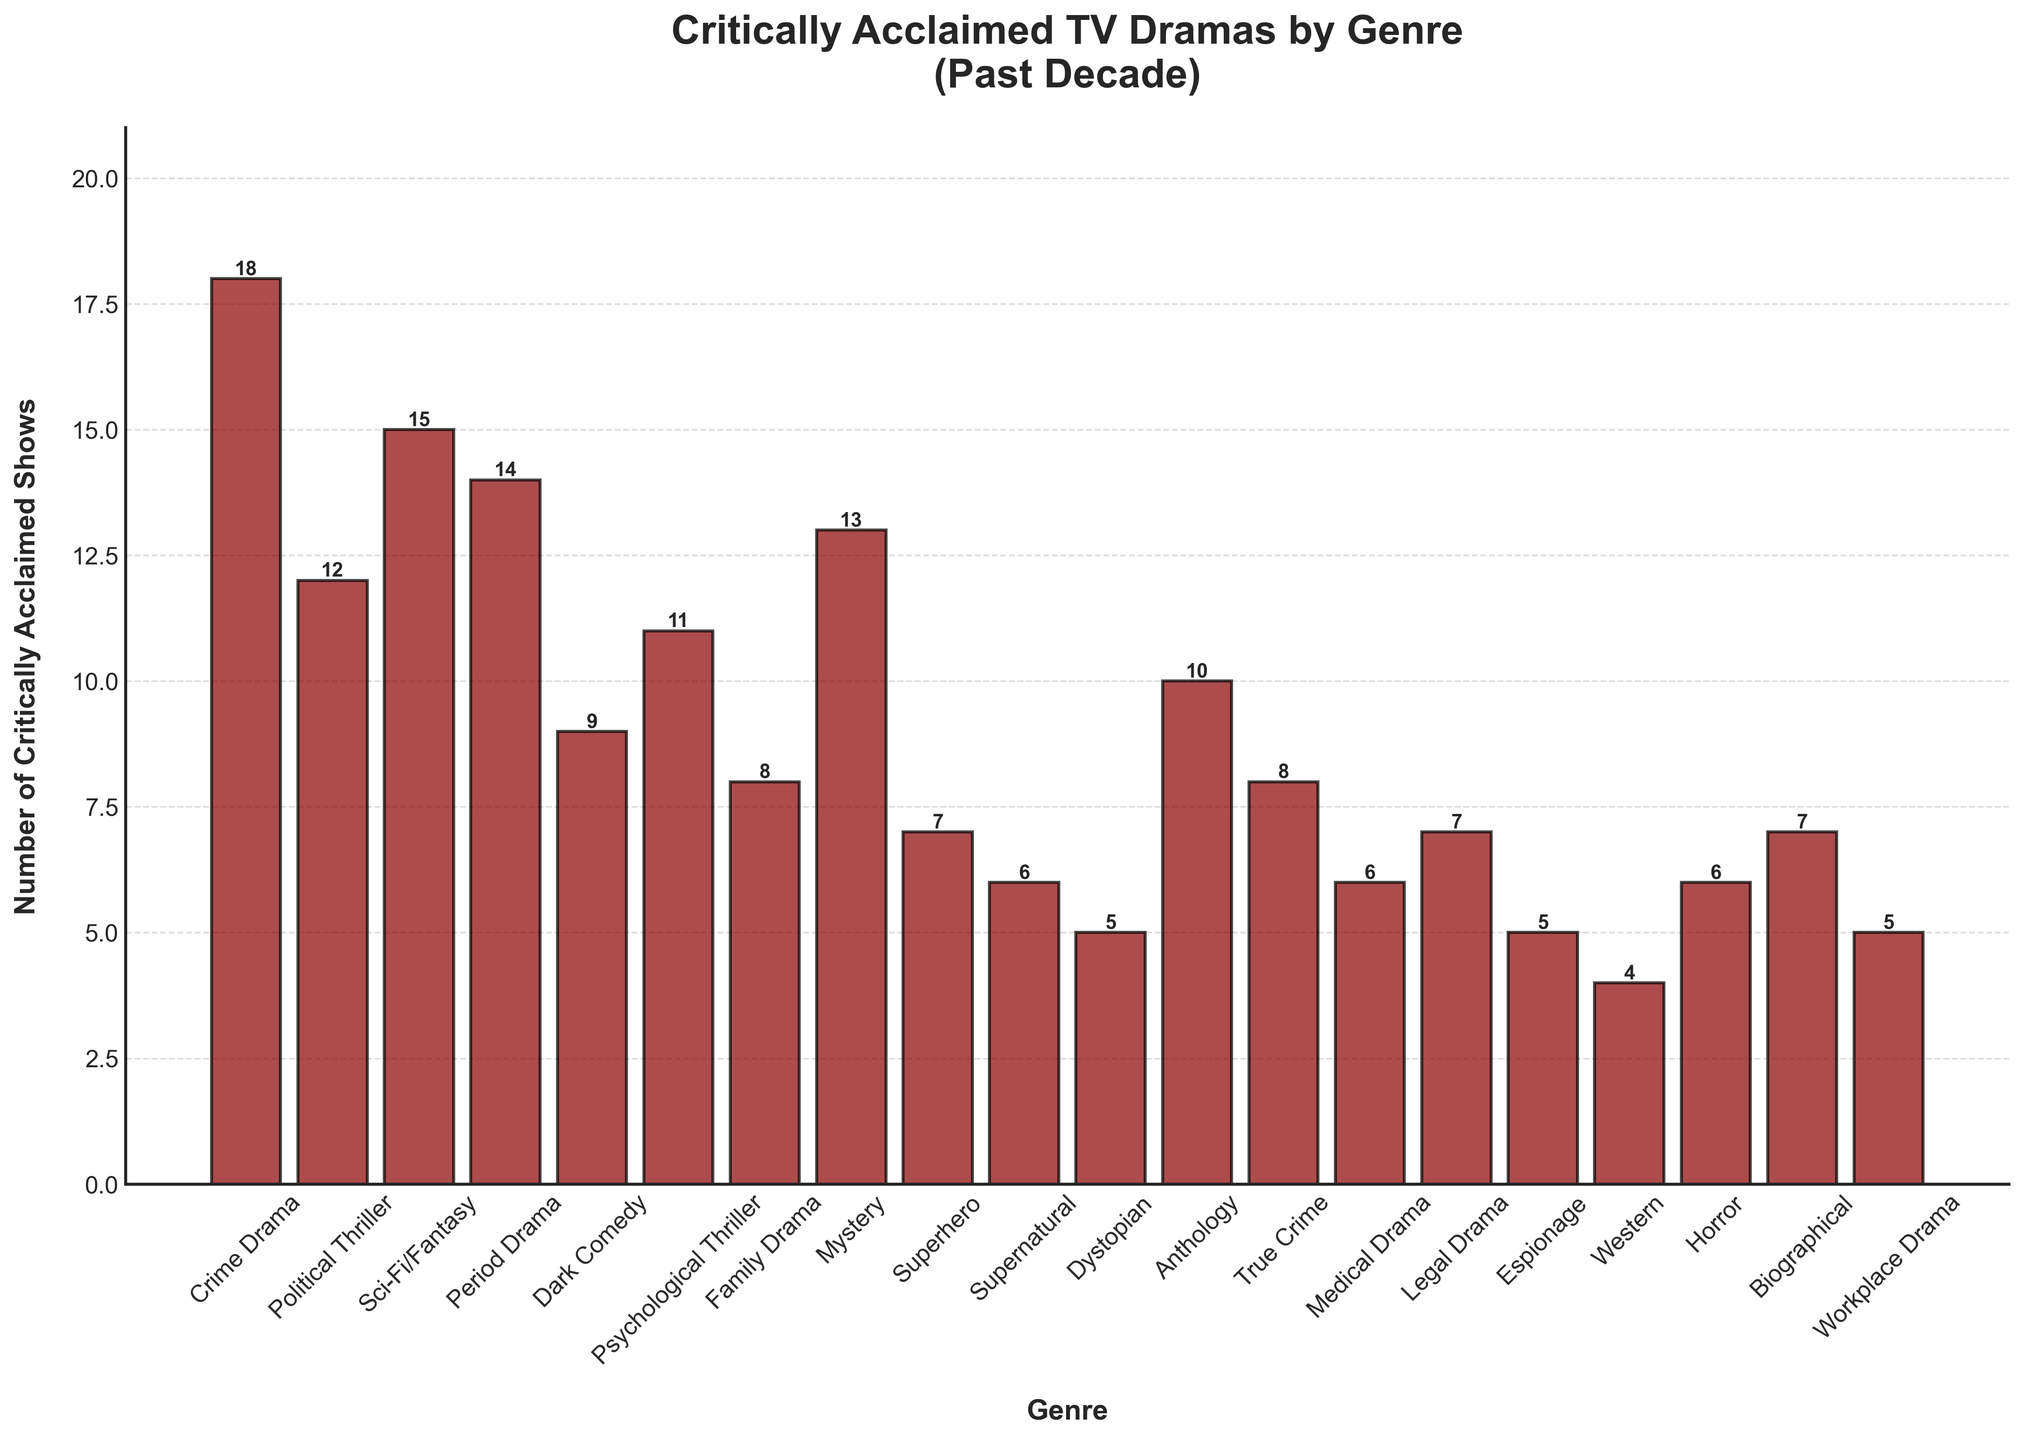Which genre has the highest number of critically acclaimed TV dramas? Identify the bar with the highest height on the chart. The tallest bar corresponds to the Crime Drama genre, which has a height of 18.
Answer: Crime Drama Which genre has more critically acclaimed shows, Medical Drama or Horror? Compare the heights of the bars for Medical Drama and Horror. Both bars have a height of 6, so they are equal.
Answer: Equal Which has fewer critically acclaimed TV dramas: Family Drama or Supernatural? Compare the heights of the bars for Family Drama and Supernatural. Family Drama has a height of 8, and Supernatural has a height of 6.
Answer: Supernatural What is the color of the bars in the chart? Observe the color of the bars. All bars are colored dark red.
Answer: Dark red Do any bars exceed a height of 20? Visually inspect all bars to determine if any are taller than a height of 20. The highest bar is for Crime Drama, which has a height of 18.
Answer: No What is the sum of the number of critically acclaimed shows in Crime Drama, Sci-Fi/Fantasy, and Period Drama? Add the heights of the bars for Crime Drama (18), Sci-Fi/Fantasy (15), and Period Drama (14). 18 + 15 + 14 = 47.
Answer: 47 What is the difference in the number of critically acclaimed shows between Crime Drama and Superhero? Subtract the height of the Superhero bar (7) from the height of the Crime Drama bar (18). 18 - 7 = 11.
Answer: 11 What's the average number of critically acclaimed shows across the genres? Sum the heights of all the bars and divide by the total number of genres (20). Sum: 18 + 12 + 15 + 14 + 9 + 11 + 8 + 13 + 7 + 6 + 5 + 10 + 8 + 6 + 7 + 5 + 4 + 6 + 7 + 5 = 176. Average: 176 / 20 = 8.8.
Answer: 8.8 How many genres have a single-digit number of critically acclaimed shows? Count the bars that have heights less than 10. These genres are Dark Comedy (9), Family Drama (8), Superhero (7), Supernatural (6), Dystopian (5), Medical Drama (6), Legal Drama (7), Espionage (5), Western (4), Horror (6), Biographical (7), and Workplace Drama (5).
Answer: 12 